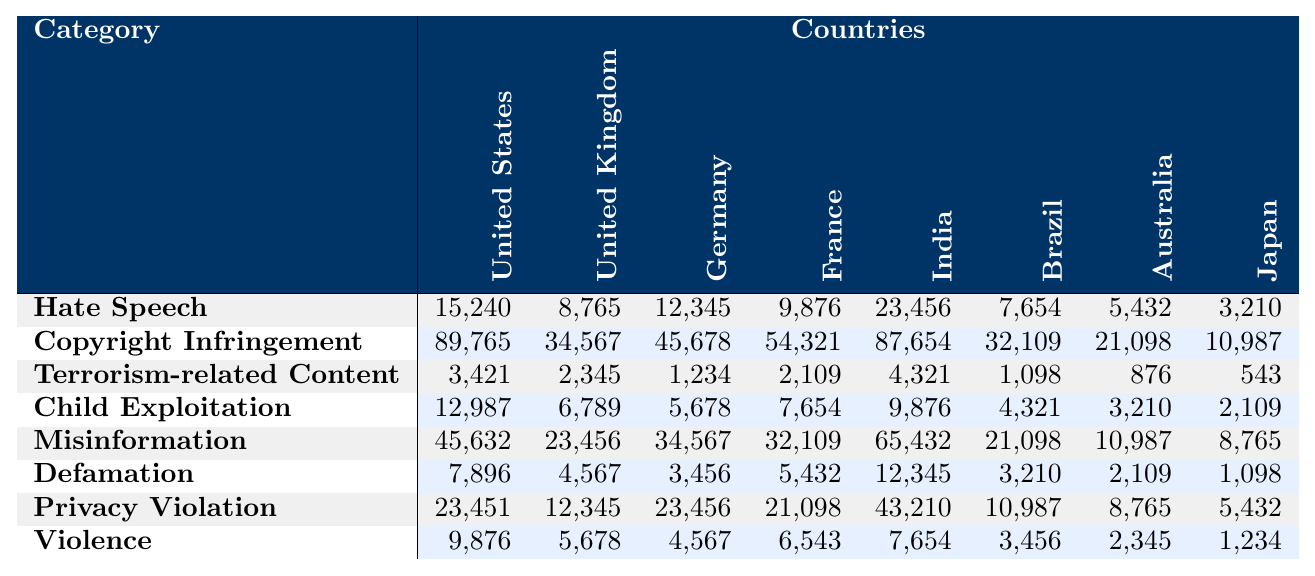What is the highest number of online content removal requests in the United States? Referring to the table, the highest number of removal requests in the United States is for Copyright Infringement, which has a total of 89,765 requests.
Answer: 89,765 Which country has the fewest removal requests for Hate Speech? In the table, Japan has the fewest removal requests for Hate Speech, with a total of 3,210 requests.
Answer: 3,210 What is the total number of removal requests for Child Exploitation across all listed countries? To find the total, we sum the requests: 12,987 + 6,789 + 5,678 + 7,654 + 9,876 + 4,321 + 3,210 + 2,109 = 52,624.
Answer: 52,624 Did India have more removal requests for Misinformation compared to the United Kingdom? In the table, India has 65,432 requests for Misinformation, while the United Kingdom has 23,456 requests. Therefore, India had significantly more requests.
Answer: Yes What is the average number of removal requests for Privacy Violation across all countries? To calculate the average, first sum the requests: 23,451 + 12,345 + 23,456 + 21,098 + 43,210 + 10,987 + 8,765 + 5,432 = 145,764. Then divide by the number of countries (8), resulting in an average of 145,764 / 8 = 18,220.5.
Answer: 18,220.5 Which category of removal requests has the highest total across all countries? By summing each category, we find: Hate Speech = 15,240 + 8,765 + 12,345 + 9,876 + 23,456 + 7,654 + 5,432 + 3,210 = 85,028; Copyright Infringement = 89,765 + 34,567 + 45,678 + 54,321 + 87,654 + 32,109 + 21,098 + 10,987 = 384,360; Upon comparing, Copyright Infringement has the highest total.
Answer: Copyright Infringement How many more requests for Defamation did the United States have compared to Australia? Looking at the respective numbers, the United States had 7,896 requests while Australia had 2,109. The difference is 7,896 - 2,109 = 5,787.
Answer: 5,787 Is the total number of requests for Terrorism-related Content greater in Germany than in Brazil? In Germany, the number is 1,234, while in Brazil it is 1,098. Thus, Germany has more requests for that category.
Answer: Yes What is the total number of removal requests for Violence in the United Kingdom and France combined? The total for Violence in the UK is 5,678 and in France is 6,543. Adding these together gives 5,678 + 6,543 = 12,221.
Answer: 12,221 Which country has the highest number of removal requests for Copyright Infringement, and what is that number? The table shows that India has the highest number of requests for Copyright Infringement with a total of 87,654.
Answer: India; 87,654 